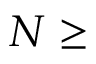Convert formula to latex. <formula><loc_0><loc_0><loc_500><loc_500>N \geq</formula> 